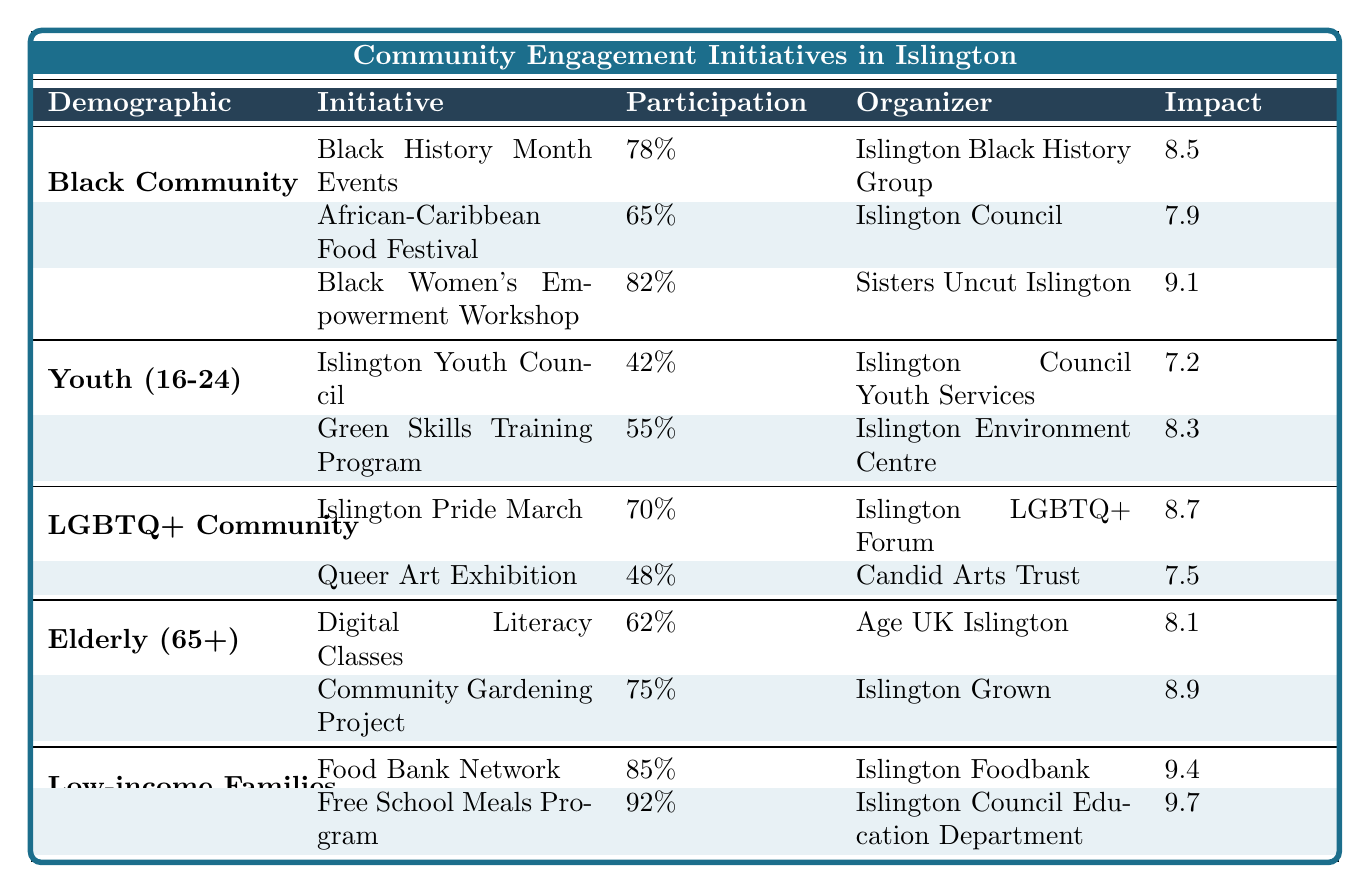What is the participation rate for the "Black Women's Empowerment Workshop"? The "Black Women's Empowerment Workshop" initiative has a participation rate of 82% as indicated in the table under the Black Community section.
Answer: 82% Which community initiative has the highest impact score? The "Free School Meals Program" for Low-income Families has the highest impact score of 9.7, as shown in the table.
Answer: 9.7 How many initiatives are there for the LGBTQ+ Community? There are two initiatives listed for the LGBTQ+ Community: the "Islington Pride March" and the "Queer Art Exhibition."
Answer: 2 What is the average participation rate for initiatives targeted at the Elderly (65+)? The participation rates for initiatives for the Elderly are 62% and 75%. The average is (62 + 75) / 2 = 68.5%.
Answer: 68.5% True or False: The participation rate for the "Green Skills Training Program" is greater than 50%. The participation rate for the "Green Skills Training Program" is 55%, which is greater than 50%. Therefore, the statement is true.
Answer: True Which demographic had the highest overall participation in community initiatives? The Low-income Families demographic had the highest participation rates for both initiatives listed: 85% and 92%, averaging 88.5%. This is higher than other demographics.
Answer: Low-income Families If you were to combine the participation rates for both initiatives in the Black Community, what would that total be? The participation rates for the Black Community initiatives are 78% + 65% + 82%. Summing these gives 225%.
Answer: 225% What is the impact score difference between the "Community Gardening Project" and the "Islington Youth Council"? The impact score for the "Community Gardening Project" is 8.9 and for the "Islington Youth Council" it is 7.2. The difference is 8.9 - 7.2 = 1.7.
Answer: 1.7 How many organizers participated in the initiatives listed for Youth (16-24)? There is one organizer listed for each of the two initiatives for Youth, totaling 2 unique organizers: Islington Council Youth Services and Islington Environment Centre.
Answer: 2 Which initiative has a lower participation rate: the "African-Caribbean Food Festival" or the "Digital Literacy Classes"? The "African-Caribbean Food Festival" has a participation rate of 65%, while the "Digital Literacy Classes" have 62%. Comparing these shows that the "Digital Literacy Classes" have a lower participation rate.
Answer: Digital Literacy Classes 